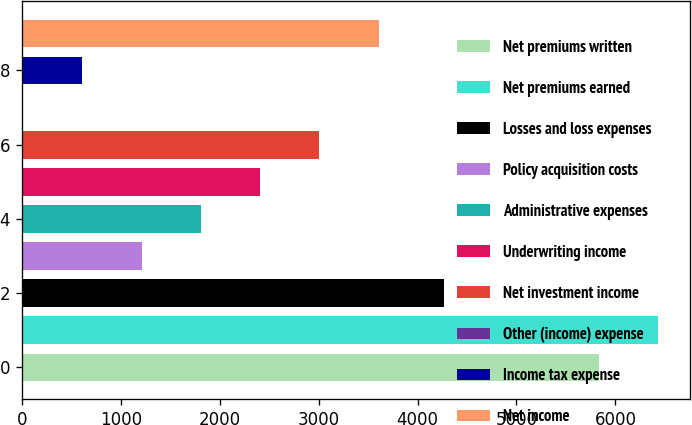Convert chart to OTSL. <chart><loc_0><loc_0><loc_500><loc_500><bar_chart><fcel>Net premiums written<fcel>Net premiums earned<fcel>Losses and loss expenses<fcel>Policy acquisition costs<fcel>Administrative expenses<fcel>Underwriting income<fcel>Net investment income<fcel>Other (income) expense<fcel>Income tax expense<fcel>Net income<nl><fcel>5833<fcel>6432.6<fcel>4269<fcel>1210.2<fcel>1809.8<fcel>2409.4<fcel>3009<fcel>11<fcel>610.6<fcel>3608.6<nl></chart> 